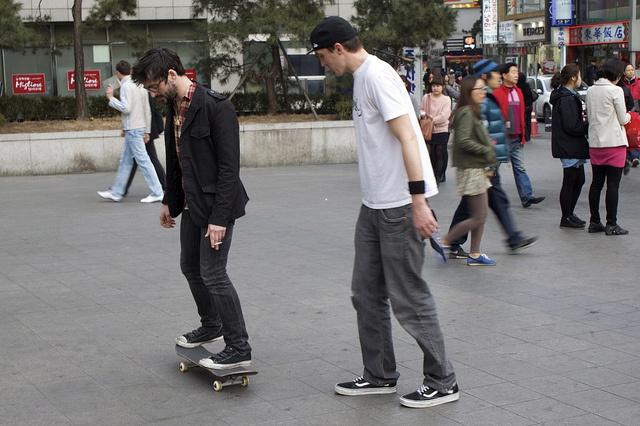Describe the objects in this image and their specific colors. I can see people in darkgreen, black, gray, lightgray, and darkgray tones, people in darkgreen, black, gray, darkgray, and maroon tones, people in darkgreen, gray, black, and darkgray tones, people in darkgreen, black, lightgray, darkgray, and brown tones, and people in darkgreen, black, gray, maroon, and darkgray tones in this image. 